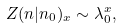Convert formula to latex. <formula><loc_0><loc_0><loc_500><loc_500>Z ( { n } | { n _ { 0 } } ) _ { x } \sim \lambda _ { 0 } ^ { x } ,</formula> 